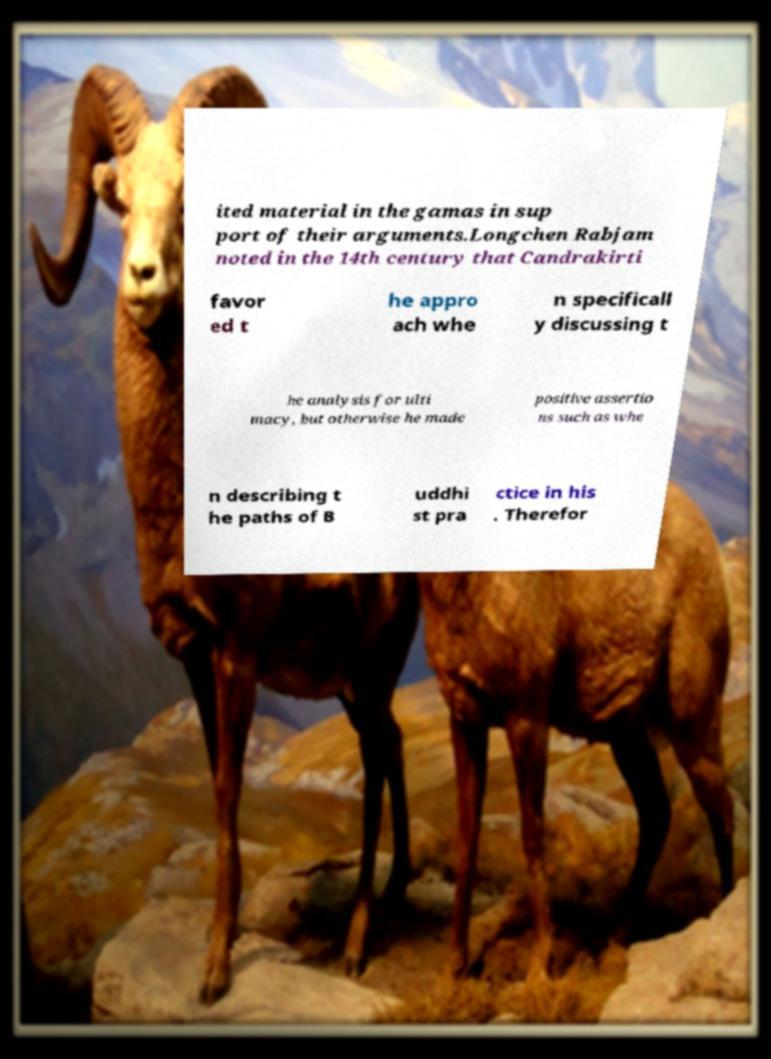Could you extract and type out the text from this image? ited material in the gamas in sup port of their arguments.Longchen Rabjam noted in the 14th century that Candrakirti favor ed t he appro ach whe n specificall y discussing t he analysis for ulti macy, but otherwise he made positive assertio ns such as whe n describing t he paths of B uddhi st pra ctice in his . Therefor 